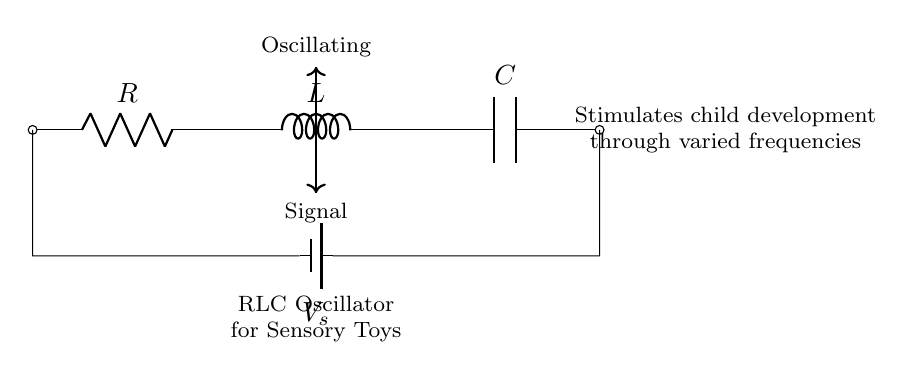What type of circuit is shown? The circuit consists of a resistor, inductor, and capacitor connected in series, which classifies it as an RLC circuit.
Answer: RLC circuit What is the purpose of the battery in the circuit? The battery provides a constant voltage source, labeled as V_s, which drives the current through the RLC components, enabling the oscillator to function.
Answer: Voltage source Which component is represented by the letter L? The letter L indicates the inductor in the circuit, which stores energy in its magnetic field when current flows through it.
Answer: Inductor What effect do varied frequencies have on child development? The circuit is designed to produce oscillating signals at various frequencies, which promote sensory stimulation and assist in developmental growth in children.
Answer: Sensory stimulation How many components are in this circuit? The circuit contains three components: one resistor, one inductor, and one capacitor, which work together in the RLC configuration.
Answer: Three Why is the circuit labeled as an oscillator? The circuit's configuration allows it to produce oscillations due to the interaction between the resistor, inductor, and capacitor, generating alternating signals necessary for the oscillating effect.
Answer: Oscillating effect What is the label for the capacitor in this diagram? The capacitor is labeled as C in the circuit, which is the standard notation for capacitance in electrical diagrams.
Answer: C 